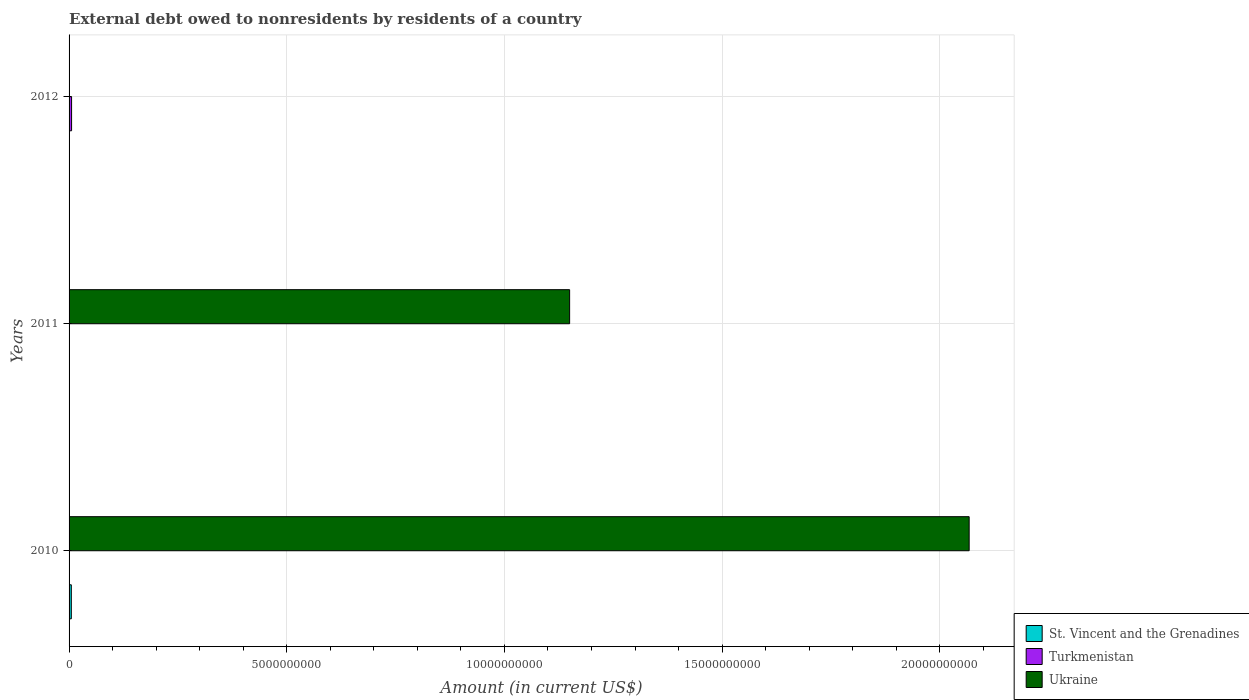Are the number of bars per tick equal to the number of legend labels?
Offer a very short reply. No. Are the number of bars on each tick of the Y-axis equal?
Offer a terse response. No. How many bars are there on the 1st tick from the top?
Your response must be concise. 1. How many bars are there on the 3rd tick from the bottom?
Your answer should be compact. 1. What is the label of the 2nd group of bars from the top?
Make the answer very short. 2011. What is the external debt owed by residents in Turkmenistan in 2011?
Provide a short and direct response. 0. Across all years, what is the maximum external debt owed by residents in St. Vincent and the Grenadines?
Make the answer very short. 5.17e+07. Across all years, what is the minimum external debt owed by residents in Ukraine?
Ensure brevity in your answer.  0. In which year was the external debt owed by residents in St. Vincent and the Grenadines maximum?
Ensure brevity in your answer.  2010. What is the total external debt owed by residents in Ukraine in the graph?
Your response must be concise. 3.22e+1. What is the difference between the external debt owed by residents in Ukraine in 2010 and that in 2011?
Provide a succinct answer. 9.18e+09. What is the difference between the external debt owed by residents in St. Vincent and the Grenadines in 2010 and the external debt owed by residents in Turkmenistan in 2011?
Your response must be concise. 5.17e+07. What is the average external debt owed by residents in Turkmenistan per year?
Your response must be concise. 1.92e+07. In the year 2011, what is the difference between the external debt owed by residents in Ukraine and external debt owed by residents in St. Vincent and the Grenadines?
Your answer should be very brief. 1.15e+1. What is the difference between the highest and the lowest external debt owed by residents in Turkmenistan?
Give a very brief answer. 5.76e+07. In how many years, is the external debt owed by residents in Ukraine greater than the average external debt owed by residents in Ukraine taken over all years?
Keep it short and to the point. 2. Is the sum of the external debt owed by residents in Ukraine in 2010 and 2011 greater than the maximum external debt owed by residents in St. Vincent and the Grenadines across all years?
Offer a very short reply. Yes. How many bars are there?
Your answer should be compact. 5. Are all the bars in the graph horizontal?
Keep it short and to the point. Yes. Are the values on the major ticks of X-axis written in scientific E-notation?
Provide a succinct answer. No. Does the graph contain grids?
Give a very brief answer. Yes. Where does the legend appear in the graph?
Your answer should be compact. Bottom right. What is the title of the graph?
Keep it short and to the point. External debt owed to nonresidents by residents of a country. Does "OECD members" appear as one of the legend labels in the graph?
Your answer should be compact. No. What is the label or title of the X-axis?
Keep it short and to the point. Amount (in current US$). What is the Amount (in current US$) of St. Vincent and the Grenadines in 2010?
Give a very brief answer. 5.17e+07. What is the Amount (in current US$) in Ukraine in 2010?
Offer a very short reply. 2.07e+1. What is the Amount (in current US$) in St. Vincent and the Grenadines in 2011?
Your response must be concise. 8.28e+06. What is the Amount (in current US$) in Ukraine in 2011?
Your response must be concise. 1.15e+1. What is the Amount (in current US$) in Turkmenistan in 2012?
Ensure brevity in your answer.  5.76e+07. What is the Amount (in current US$) in Ukraine in 2012?
Give a very brief answer. 0. Across all years, what is the maximum Amount (in current US$) of St. Vincent and the Grenadines?
Provide a succinct answer. 5.17e+07. Across all years, what is the maximum Amount (in current US$) of Turkmenistan?
Offer a terse response. 5.76e+07. Across all years, what is the maximum Amount (in current US$) of Ukraine?
Offer a terse response. 2.07e+1. Across all years, what is the minimum Amount (in current US$) in St. Vincent and the Grenadines?
Make the answer very short. 0. Across all years, what is the minimum Amount (in current US$) of Turkmenistan?
Your response must be concise. 0. What is the total Amount (in current US$) of St. Vincent and the Grenadines in the graph?
Offer a very short reply. 5.99e+07. What is the total Amount (in current US$) in Turkmenistan in the graph?
Give a very brief answer. 5.76e+07. What is the total Amount (in current US$) of Ukraine in the graph?
Provide a succinct answer. 3.22e+1. What is the difference between the Amount (in current US$) of St. Vincent and the Grenadines in 2010 and that in 2011?
Your answer should be compact. 4.34e+07. What is the difference between the Amount (in current US$) in Ukraine in 2010 and that in 2011?
Offer a very short reply. 9.18e+09. What is the difference between the Amount (in current US$) of St. Vincent and the Grenadines in 2010 and the Amount (in current US$) of Ukraine in 2011?
Offer a very short reply. -1.14e+1. What is the difference between the Amount (in current US$) in St. Vincent and the Grenadines in 2010 and the Amount (in current US$) in Turkmenistan in 2012?
Keep it short and to the point. -6.00e+06. What is the difference between the Amount (in current US$) in St. Vincent and the Grenadines in 2011 and the Amount (in current US$) in Turkmenistan in 2012?
Make the answer very short. -4.94e+07. What is the average Amount (in current US$) in St. Vincent and the Grenadines per year?
Your answer should be very brief. 2.00e+07. What is the average Amount (in current US$) in Turkmenistan per year?
Your answer should be very brief. 1.92e+07. What is the average Amount (in current US$) in Ukraine per year?
Give a very brief answer. 1.07e+1. In the year 2010, what is the difference between the Amount (in current US$) of St. Vincent and the Grenadines and Amount (in current US$) of Ukraine?
Make the answer very short. -2.06e+1. In the year 2011, what is the difference between the Amount (in current US$) in St. Vincent and the Grenadines and Amount (in current US$) in Ukraine?
Your response must be concise. -1.15e+1. What is the ratio of the Amount (in current US$) in St. Vincent and the Grenadines in 2010 to that in 2011?
Offer a very short reply. 6.24. What is the ratio of the Amount (in current US$) of Ukraine in 2010 to that in 2011?
Keep it short and to the point. 1.8. What is the difference between the highest and the lowest Amount (in current US$) of St. Vincent and the Grenadines?
Your response must be concise. 5.17e+07. What is the difference between the highest and the lowest Amount (in current US$) in Turkmenistan?
Make the answer very short. 5.76e+07. What is the difference between the highest and the lowest Amount (in current US$) of Ukraine?
Give a very brief answer. 2.07e+1. 